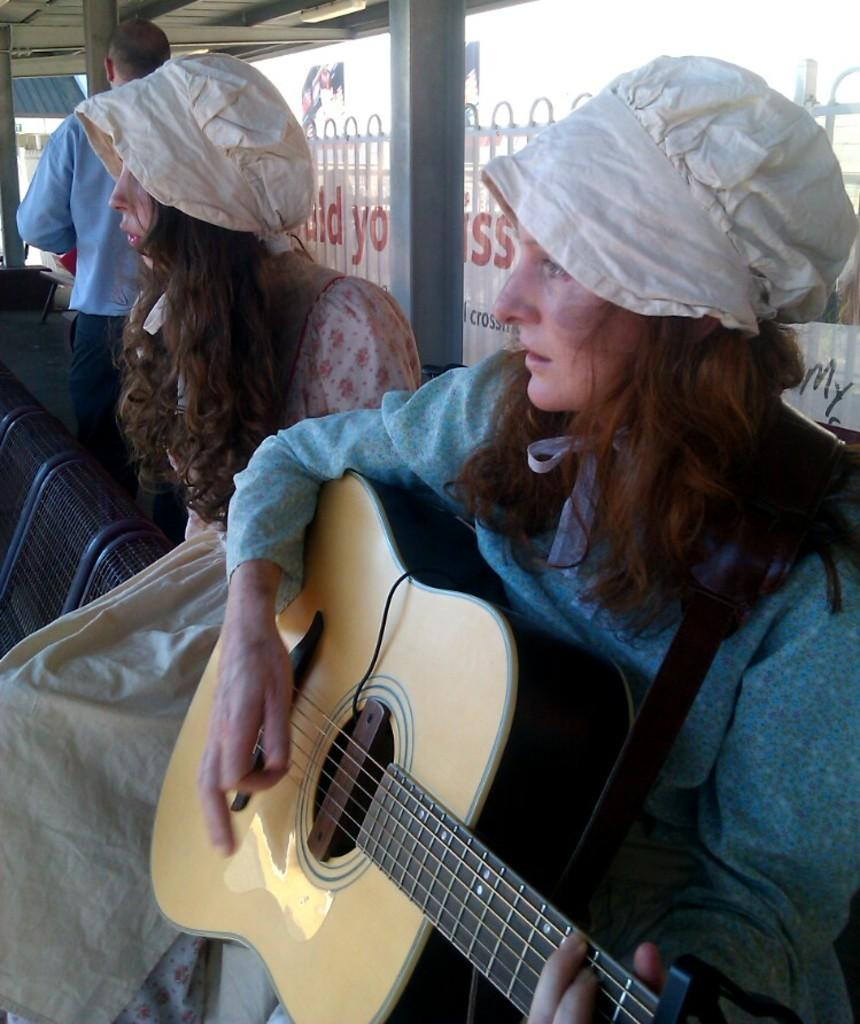How many people are in the image? There is a group of people in the image. What are the people in the image doing? The people are sitting around a table and eating food. Can you describe the setting where the people are eating? The setting is not specified, but the people are sitting around a table. What might be the occasion for this gathering? The occasion is not mentioned in the image, but it could be a meal with friends or family. Are there any mice visible in the image? A: No, there are no mice present in the image. Is the food being served hot in the image? The temperature of the food is not mentioned in the image, so it cannot be determined from the picture. 